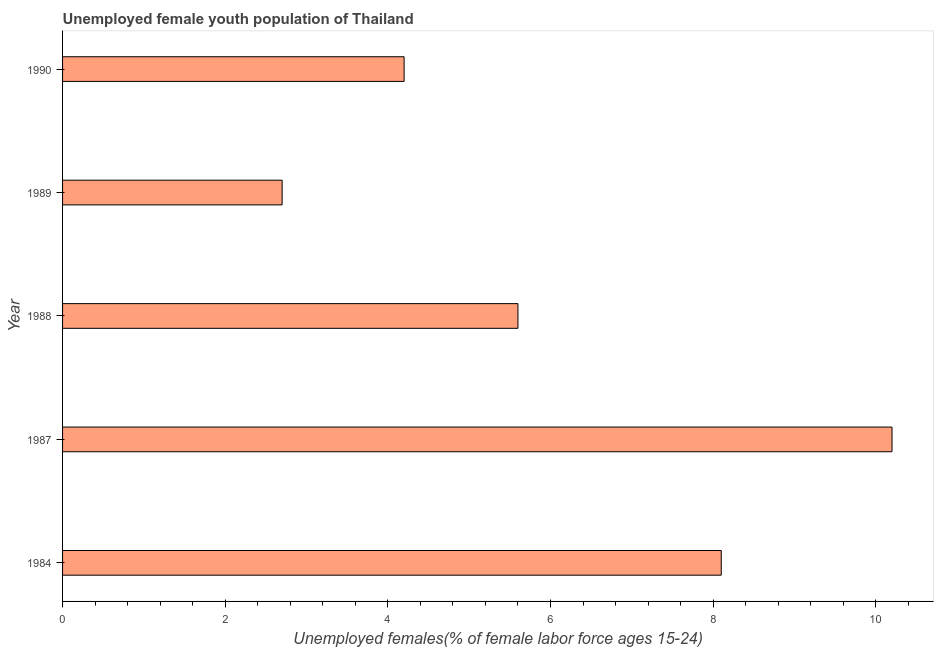Does the graph contain grids?
Offer a very short reply. No. What is the title of the graph?
Offer a terse response. Unemployed female youth population of Thailand. What is the label or title of the X-axis?
Your answer should be very brief. Unemployed females(% of female labor force ages 15-24). What is the label or title of the Y-axis?
Offer a very short reply. Year. What is the unemployed female youth in 1988?
Make the answer very short. 5.6. Across all years, what is the maximum unemployed female youth?
Ensure brevity in your answer.  10.2. Across all years, what is the minimum unemployed female youth?
Keep it short and to the point. 2.7. What is the sum of the unemployed female youth?
Provide a short and direct response. 30.8. What is the average unemployed female youth per year?
Make the answer very short. 6.16. What is the median unemployed female youth?
Provide a short and direct response. 5.6. In how many years, is the unemployed female youth greater than 4 %?
Your answer should be compact. 4. Do a majority of the years between 1990 and 1989 (inclusive) have unemployed female youth greater than 6 %?
Your answer should be very brief. No. What is the ratio of the unemployed female youth in 1989 to that in 1990?
Give a very brief answer. 0.64. What is the difference between the highest and the second highest unemployed female youth?
Ensure brevity in your answer.  2.1. Is the sum of the unemployed female youth in 1984 and 1989 greater than the maximum unemployed female youth across all years?
Your answer should be very brief. Yes. What is the difference between the highest and the lowest unemployed female youth?
Offer a very short reply. 7.5. In how many years, is the unemployed female youth greater than the average unemployed female youth taken over all years?
Ensure brevity in your answer.  2. How many bars are there?
Give a very brief answer. 5. Are all the bars in the graph horizontal?
Keep it short and to the point. Yes. What is the difference between two consecutive major ticks on the X-axis?
Offer a terse response. 2. Are the values on the major ticks of X-axis written in scientific E-notation?
Your response must be concise. No. What is the Unemployed females(% of female labor force ages 15-24) in 1984?
Your answer should be compact. 8.1. What is the Unemployed females(% of female labor force ages 15-24) of 1987?
Your response must be concise. 10.2. What is the Unemployed females(% of female labor force ages 15-24) of 1988?
Your answer should be compact. 5.6. What is the Unemployed females(% of female labor force ages 15-24) in 1989?
Give a very brief answer. 2.7. What is the Unemployed females(% of female labor force ages 15-24) of 1990?
Ensure brevity in your answer.  4.2. What is the difference between the Unemployed females(% of female labor force ages 15-24) in 1984 and 1988?
Offer a very short reply. 2.5. What is the difference between the Unemployed females(% of female labor force ages 15-24) in 1987 and 1989?
Make the answer very short. 7.5. What is the difference between the Unemployed females(% of female labor force ages 15-24) in 1988 and 1989?
Provide a short and direct response. 2.9. What is the difference between the Unemployed females(% of female labor force ages 15-24) in 1988 and 1990?
Keep it short and to the point. 1.4. What is the difference between the Unemployed females(% of female labor force ages 15-24) in 1989 and 1990?
Offer a very short reply. -1.5. What is the ratio of the Unemployed females(% of female labor force ages 15-24) in 1984 to that in 1987?
Your answer should be compact. 0.79. What is the ratio of the Unemployed females(% of female labor force ages 15-24) in 1984 to that in 1988?
Offer a terse response. 1.45. What is the ratio of the Unemployed females(% of female labor force ages 15-24) in 1984 to that in 1989?
Your response must be concise. 3. What is the ratio of the Unemployed females(% of female labor force ages 15-24) in 1984 to that in 1990?
Provide a short and direct response. 1.93. What is the ratio of the Unemployed females(% of female labor force ages 15-24) in 1987 to that in 1988?
Provide a succinct answer. 1.82. What is the ratio of the Unemployed females(% of female labor force ages 15-24) in 1987 to that in 1989?
Ensure brevity in your answer.  3.78. What is the ratio of the Unemployed females(% of female labor force ages 15-24) in 1987 to that in 1990?
Your answer should be very brief. 2.43. What is the ratio of the Unemployed females(% of female labor force ages 15-24) in 1988 to that in 1989?
Your answer should be compact. 2.07. What is the ratio of the Unemployed females(% of female labor force ages 15-24) in 1988 to that in 1990?
Offer a terse response. 1.33. What is the ratio of the Unemployed females(% of female labor force ages 15-24) in 1989 to that in 1990?
Make the answer very short. 0.64. 